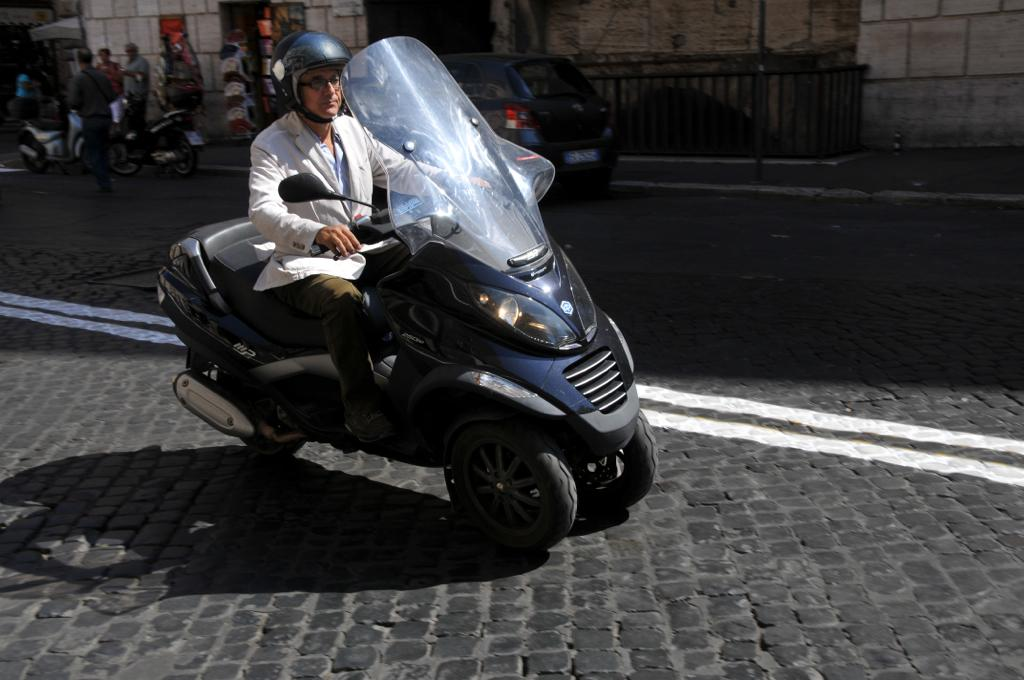What is the man doing in the image? The man is riding a vehicle in the image. Where is the vehicle located? The vehicle is on the road. What can be seen in the background of the image? In the background, there are bikes, a car, walls, a fence, and people. How many types of vehicles are visible in the image? There is one vehicle being ridden by the man, and there are bikes and a car visible in the background, making a total of three types of vehicles. What brand of toothpaste is the man using while riding the vehicle in the image? There is no toothpaste present in the image, and the man's activity does not involve using toothpaste. What stage of development is the train going through in the image? There is no train present in the image, so it is not possible to determine its stage of development. 